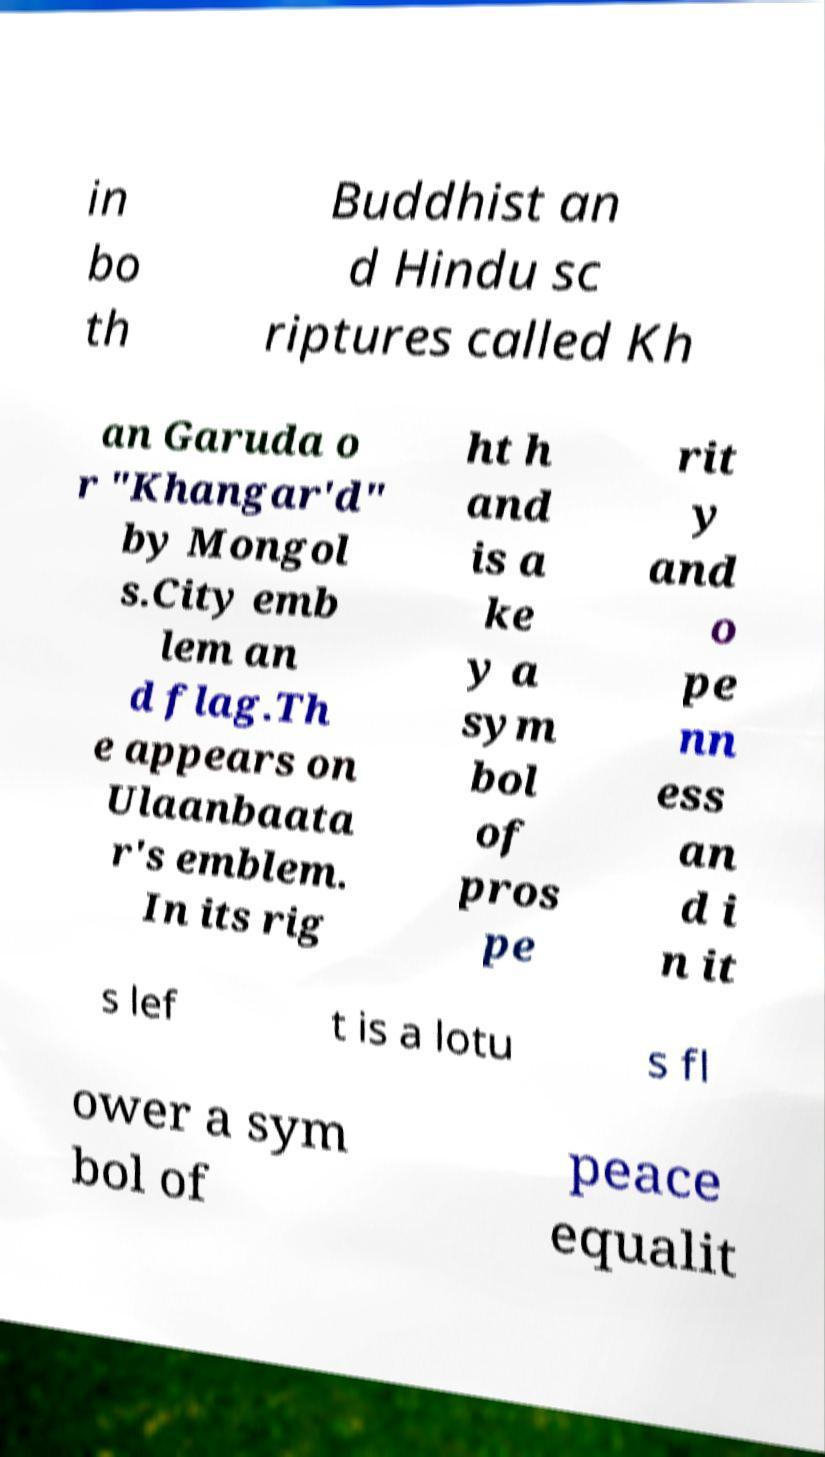Can you accurately transcribe the text from the provided image for me? in bo th Buddhist an d Hindu sc riptures called Kh an Garuda o r "Khangar'd" by Mongol s.City emb lem an d flag.Th e appears on Ulaanbaata r's emblem. In its rig ht h and is a ke y a sym bol of pros pe rit y and o pe nn ess an d i n it s lef t is a lotu s fl ower a sym bol of peace equalit 